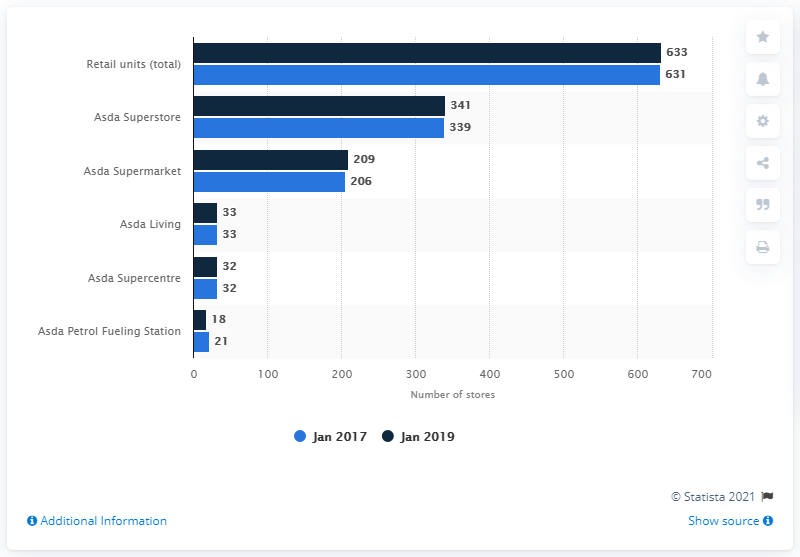Point out several critical features in this image. As of January 2017, Asda had a total of 339 stores located in the United Kingdom. As of January 2017, there were 631 Asda stores located in the United Kingdom. 